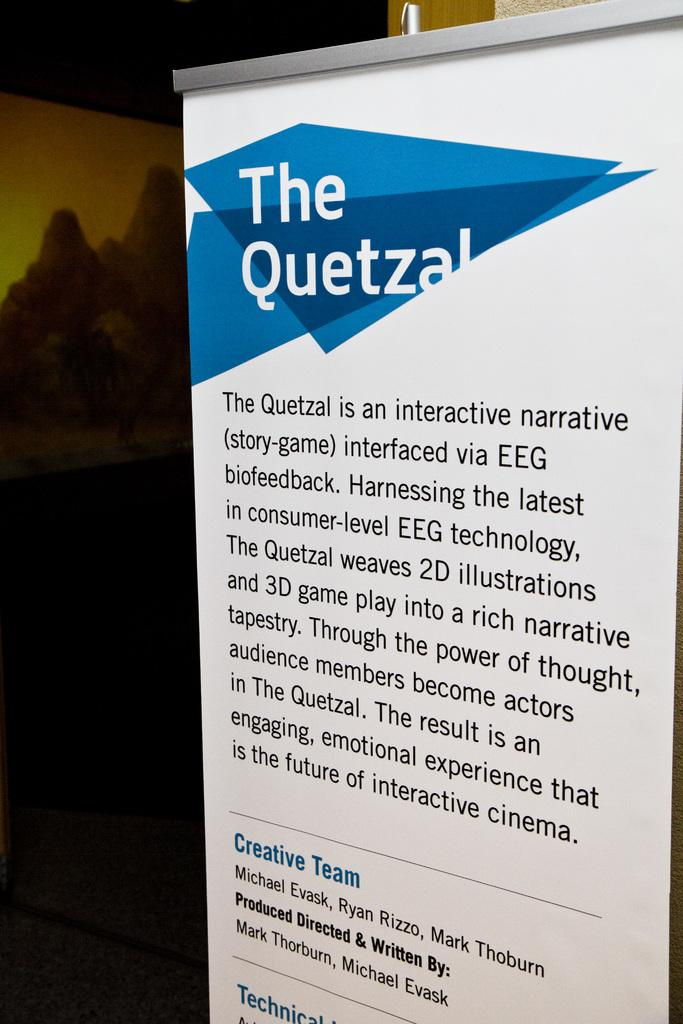Provide a one-sentence caption for the provided image. A large sign that has "The Quetzal" printed on it. 